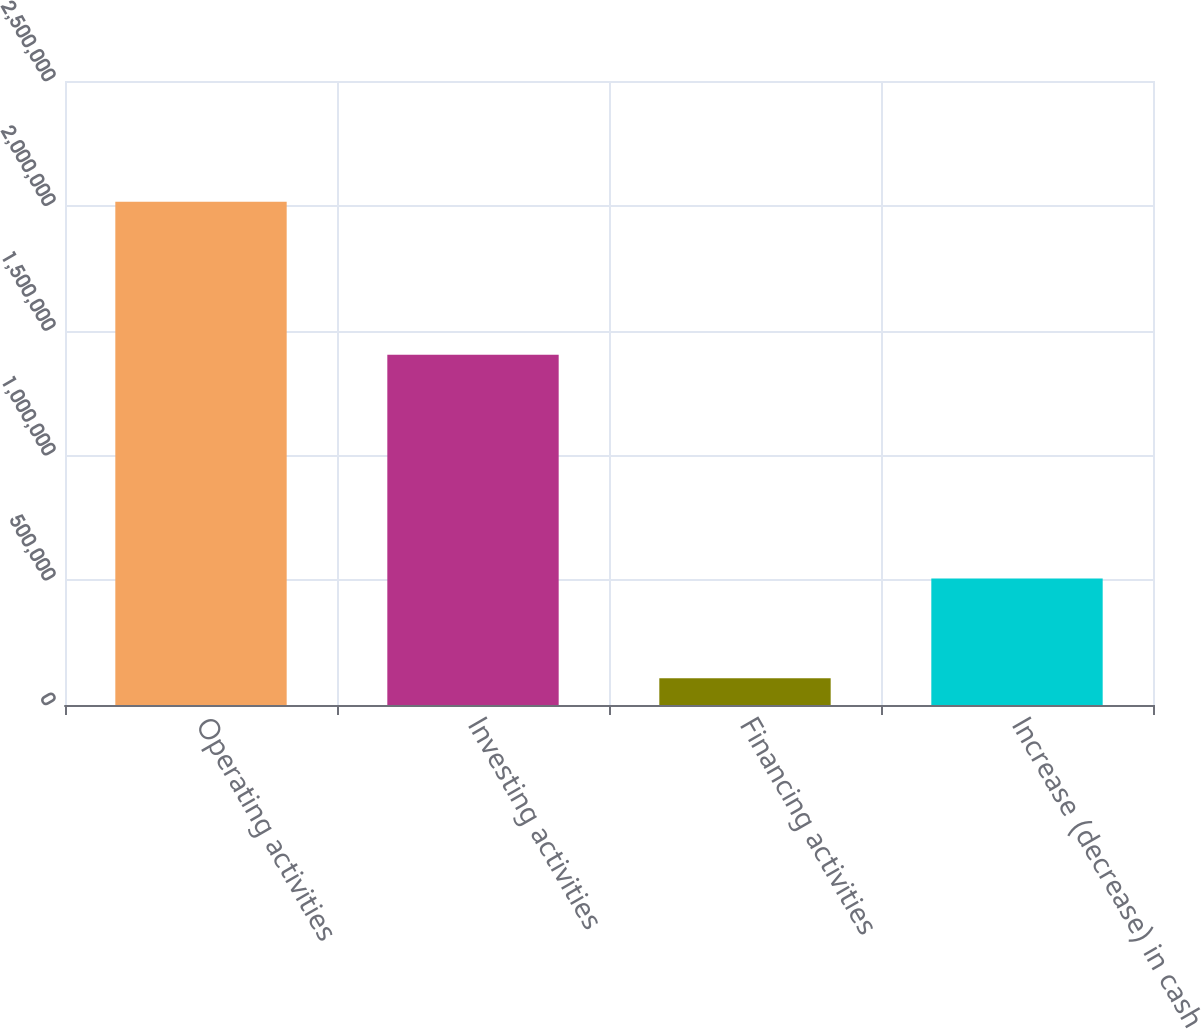Convert chart. <chart><loc_0><loc_0><loc_500><loc_500><bar_chart><fcel>Operating activities<fcel>Investing activities<fcel>Financing activities<fcel>Increase (decrease) in cash<nl><fcel>2.01657e+06<fcel>1.40309e+06<fcel>107029<fcel>506455<nl></chart> 